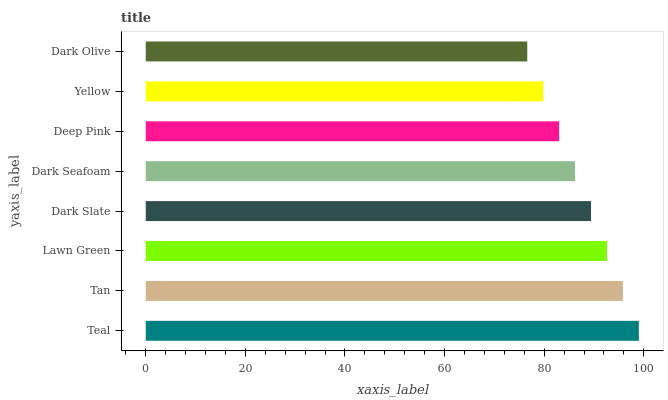Is Dark Olive the minimum?
Answer yes or no. Yes. Is Teal the maximum?
Answer yes or no. Yes. Is Tan the minimum?
Answer yes or no. No. Is Tan the maximum?
Answer yes or no. No. Is Teal greater than Tan?
Answer yes or no. Yes. Is Tan less than Teal?
Answer yes or no. Yes. Is Tan greater than Teal?
Answer yes or no. No. Is Teal less than Tan?
Answer yes or no. No. Is Dark Slate the high median?
Answer yes or no. Yes. Is Dark Seafoam the low median?
Answer yes or no. Yes. Is Dark Olive the high median?
Answer yes or no. No. Is Teal the low median?
Answer yes or no. No. 